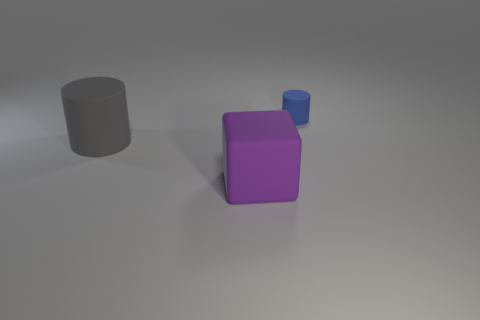Are there any other things that have the same size as the blue matte object?
Ensure brevity in your answer.  No. How many things are either tiny cyan rubber cylinders or rubber objects that are in front of the tiny matte object?
Give a very brief answer. 2. Is the number of purple things in front of the small object greater than the number of big gray cylinders behind the gray thing?
Provide a succinct answer. Yes. Are there any other things of the same color as the large cube?
Keep it short and to the point. No. How many objects are either large purple blocks or yellow cubes?
Your answer should be very brief. 1. There is a matte object that is in front of the gray thing; does it have the same size as the large gray matte cylinder?
Ensure brevity in your answer.  Yes. What number of other things are there of the same size as the purple matte thing?
Provide a short and direct response. 1. Are there any large green matte objects?
Provide a succinct answer. No. There is a cylinder that is in front of the cylinder behind the gray object; what is its size?
Offer a terse response. Large. There is a rubber object that is behind the purple matte object and on the right side of the gray cylinder; what color is it?
Keep it short and to the point. Blue. 